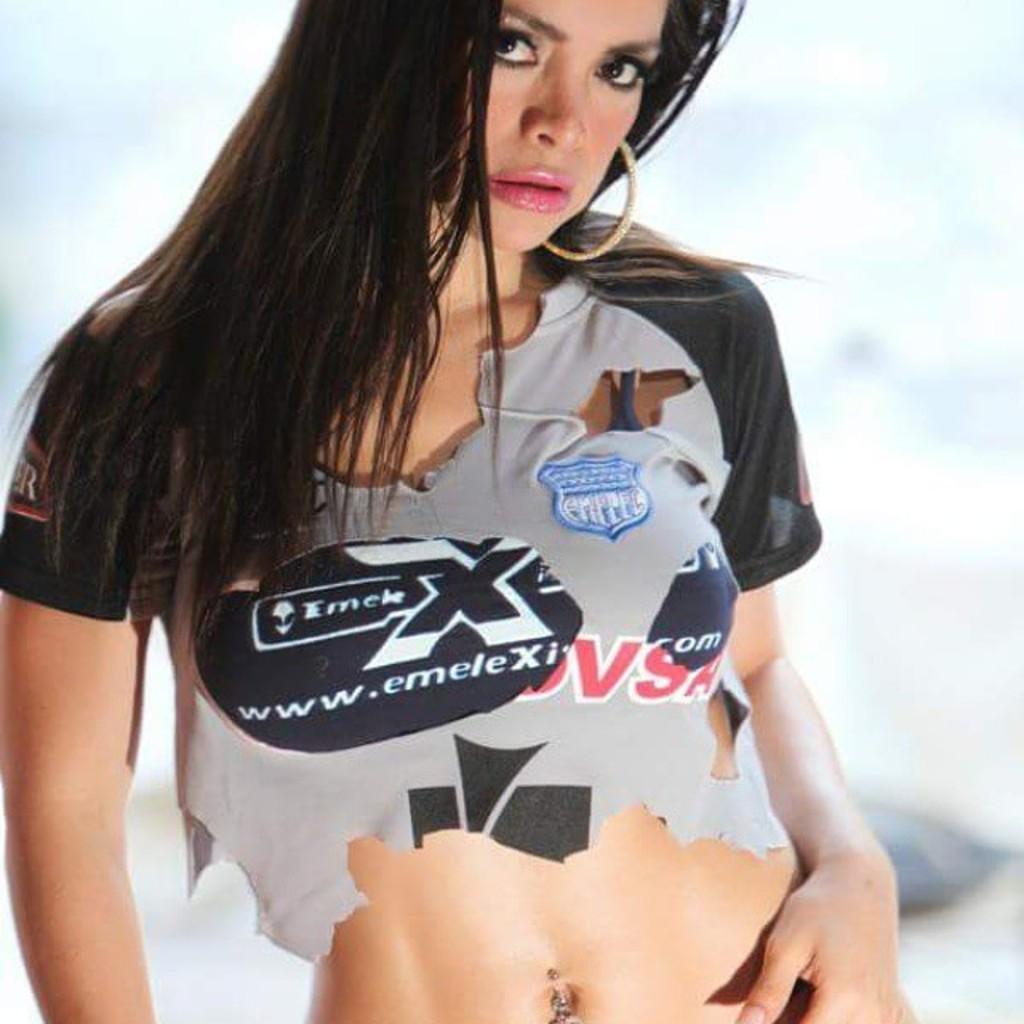What is written on her shirt?
Make the answer very short. Www.emelexi. Is emelexi a sports figure?
Provide a short and direct response. No. 